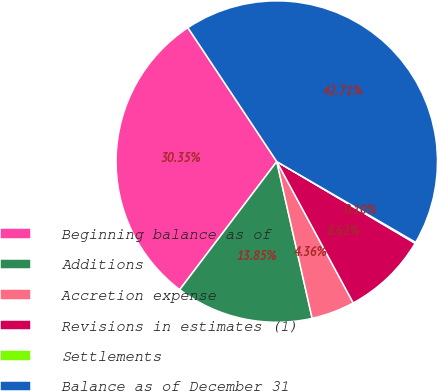<chart> <loc_0><loc_0><loc_500><loc_500><pie_chart><fcel>Beginning balance as of<fcel>Additions<fcel>Accretion expense<fcel>Revisions in estimates (1)<fcel>Settlements<fcel>Balance as of December 31<nl><fcel>30.35%<fcel>13.85%<fcel>4.36%<fcel>8.62%<fcel>0.1%<fcel>42.71%<nl></chart> 